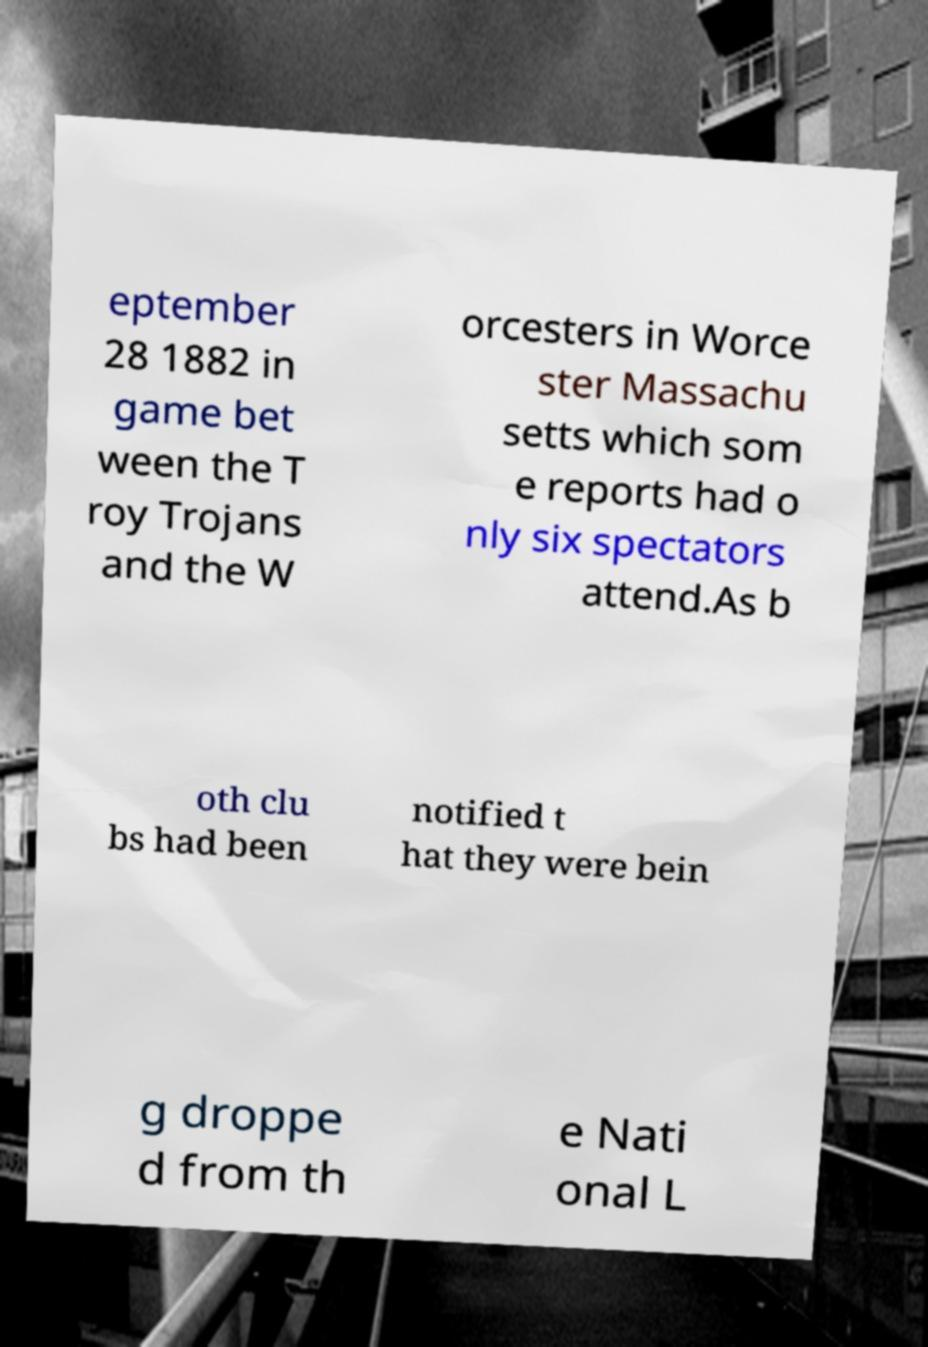I need the written content from this picture converted into text. Can you do that? eptember 28 1882 in game bet ween the T roy Trojans and the W orcesters in Worce ster Massachu setts which som e reports had o nly six spectators attend.As b oth clu bs had been notified t hat they were bein g droppe d from th e Nati onal L 